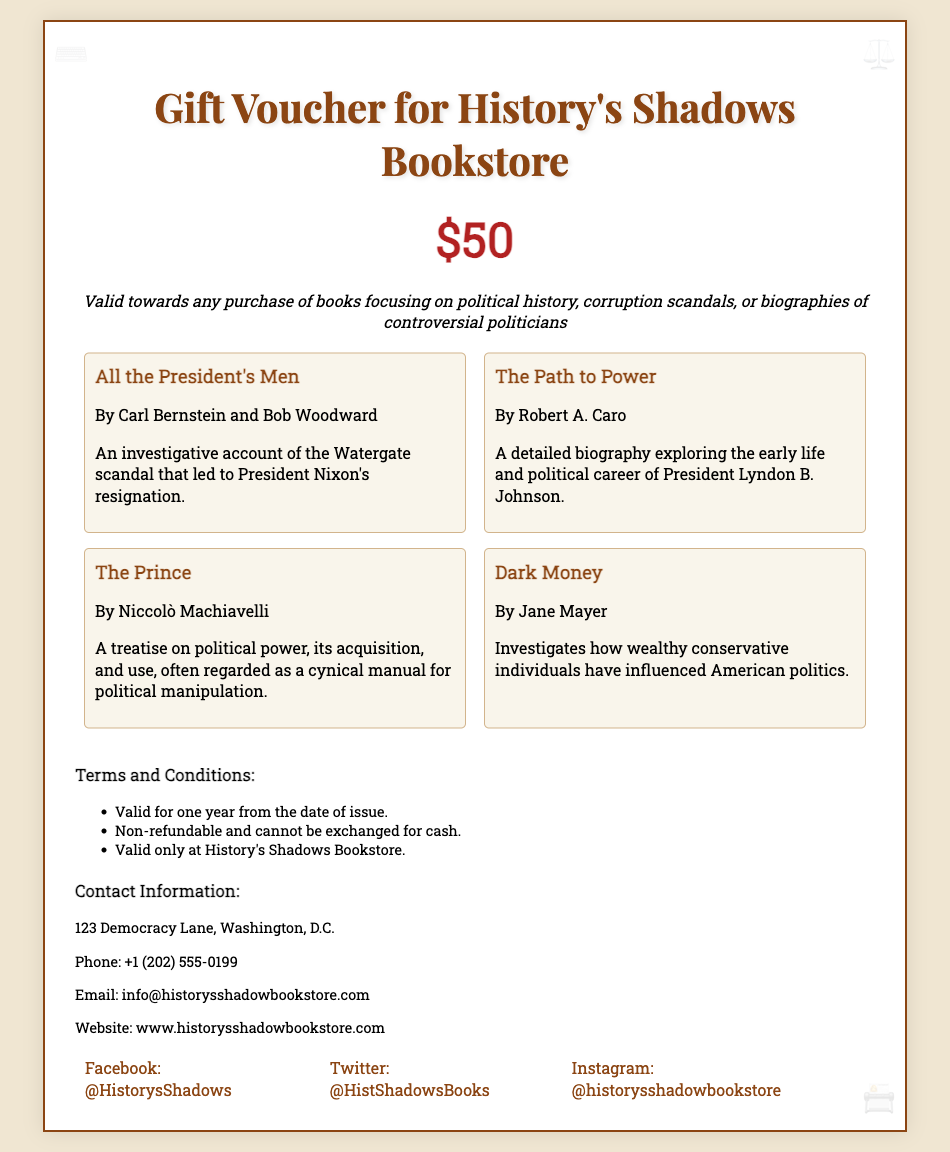What is the name of the bookstore? The name of the bookstore is displayed prominently at the top of the voucher.
Answer: History's Shadows Bookstore What is the value of the gift voucher? The value is indicated clearly in a large font within the voucher.
Answer: $50 What type of books does the voucher apply to? The description specifies the subject matter of the books eligible for purchase.
Answer: Political history, corruption scandals, or biographies of controversial politicians How many featured books are listed? The document contains a section showcasing notable books available for purchase with the voucher.
Answer: Four Who are the authors of "All the President's Men"? The authors' names are provided directly under the book title.
Answer: Carl Bernstein and Bob Woodward Is the voucher refundable? The terms state the conditions for the voucher's usage, including its refund policy.
Answer: Non-refundable What is the expiration period of the voucher? The terms and conditions mention the validity duration of the voucher.
Answer: One year What is the contact phone number listed? The contact information section provides phone details for customer inquiries.
Answer: +1 (202) 555-0199 What is one of the design elements used in the voucher? The document description includes visual details that enhance its aesthetic.
Answer: Typewriter 